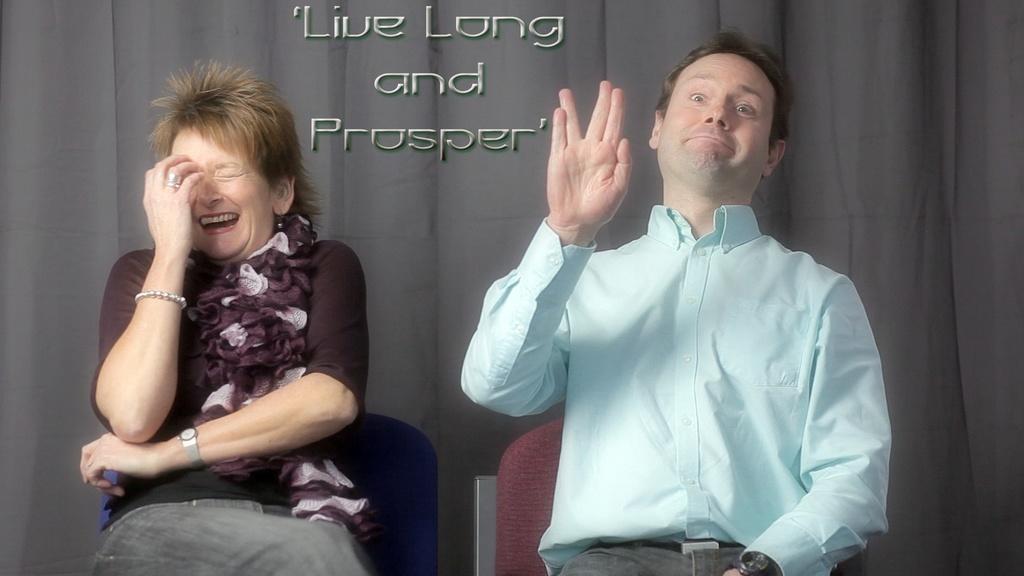Could you give a brief overview of what you see in this image? In this picture there is a man who is wearing shirt, trouser and watch. He is sitting on the chair, beside him there is a woman who is also sitting on the chair. Behind them I can see the grey color cloth. At the top there is a watermark. 